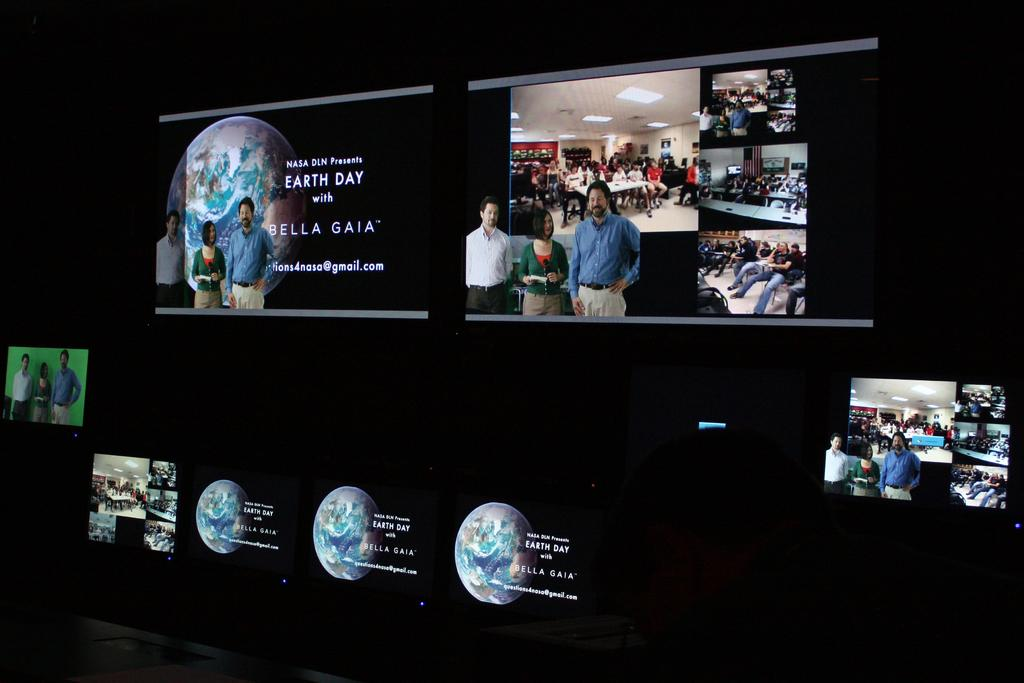What can be seen in the image? There are many displays in the image. How many cups can be seen on the kite in the image? There are no cups or kites present in the image; it only features many displays. 